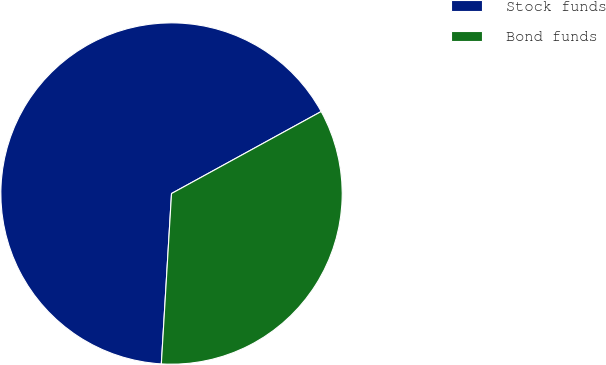Convert chart to OTSL. <chart><loc_0><loc_0><loc_500><loc_500><pie_chart><fcel>Stock funds<fcel>Bond funds<nl><fcel>66.07%<fcel>33.93%<nl></chart> 